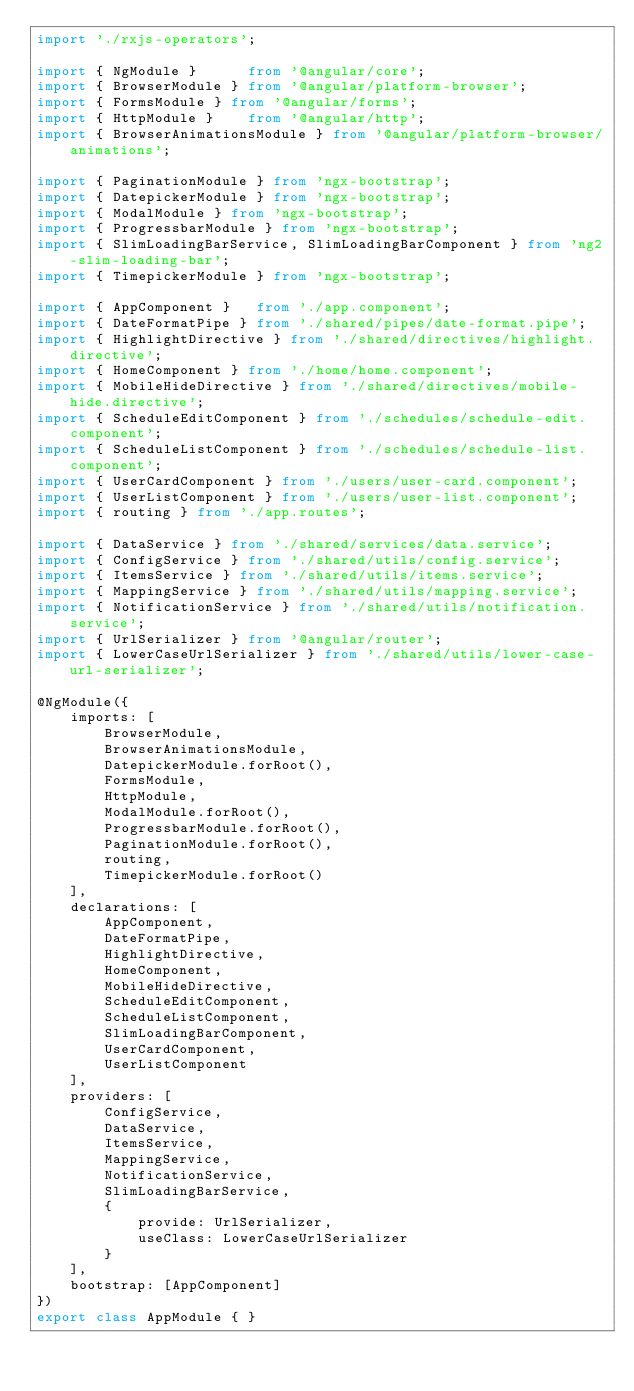Convert code to text. <code><loc_0><loc_0><loc_500><loc_500><_TypeScript_>import './rxjs-operators';

import { NgModule }      from '@angular/core';
import { BrowserModule } from '@angular/platform-browser';
import { FormsModule } from '@angular/forms';
import { HttpModule }    from '@angular/http';
import { BrowserAnimationsModule } from '@angular/platform-browser/animations';

import { PaginationModule } from 'ngx-bootstrap';
import { DatepickerModule } from 'ngx-bootstrap';
import { ModalModule } from 'ngx-bootstrap';
import { ProgressbarModule } from 'ngx-bootstrap';
import { SlimLoadingBarService, SlimLoadingBarComponent } from 'ng2-slim-loading-bar';
import { TimepickerModule } from 'ngx-bootstrap';

import { AppComponent }   from './app.component';
import { DateFormatPipe } from './shared/pipes/date-format.pipe';
import { HighlightDirective } from './shared/directives/highlight.directive';
import { HomeComponent } from './home/home.component';
import { MobileHideDirective } from './shared/directives/mobile-hide.directive';
import { ScheduleEditComponent } from './schedules/schedule-edit.component';
import { ScheduleListComponent } from './schedules/schedule-list.component';
import { UserCardComponent } from './users/user-card.component';
import { UserListComponent } from './users/user-list.component';
import { routing } from './app.routes';

import { DataService } from './shared/services/data.service';
import { ConfigService } from './shared/utils/config.service';
import { ItemsService } from './shared/utils/items.service';
import { MappingService } from './shared/utils/mapping.service';
import { NotificationService } from './shared/utils/notification.service';
import { UrlSerializer } from '@angular/router';
import { LowerCaseUrlSerializer } from './shared/utils/lower-case-url-serializer';

@NgModule({
    imports: [
        BrowserModule,
        BrowserAnimationsModule,
        DatepickerModule.forRoot(),
        FormsModule,
        HttpModule,
        ModalModule.forRoot(),
        ProgressbarModule.forRoot(),
        PaginationModule.forRoot(),
        routing,
        TimepickerModule.forRoot()
    ],
    declarations: [
        AppComponent,
        DateFormatPipe,
        HighlightDirective,
        HomeComponent,
        MobileHideDirective,
        ScheduleEditComponent,
        ScheduleListComponent,
        SlimLoadingBarComponent,
        UserCardComponent,
        UserListComponent
    ],
    providers: [
        ConfigService,
        DataService,
        ItemsService,
        MappingService,
        NotificationService,
        SlimLoadingBarService,
        {
            provide: UrlSerializer,
            useClass: LowerCaseUrlSerializer
        }
    ],
    bootstrap: [AppComponent]
})
export class AppModule { }
</code> 